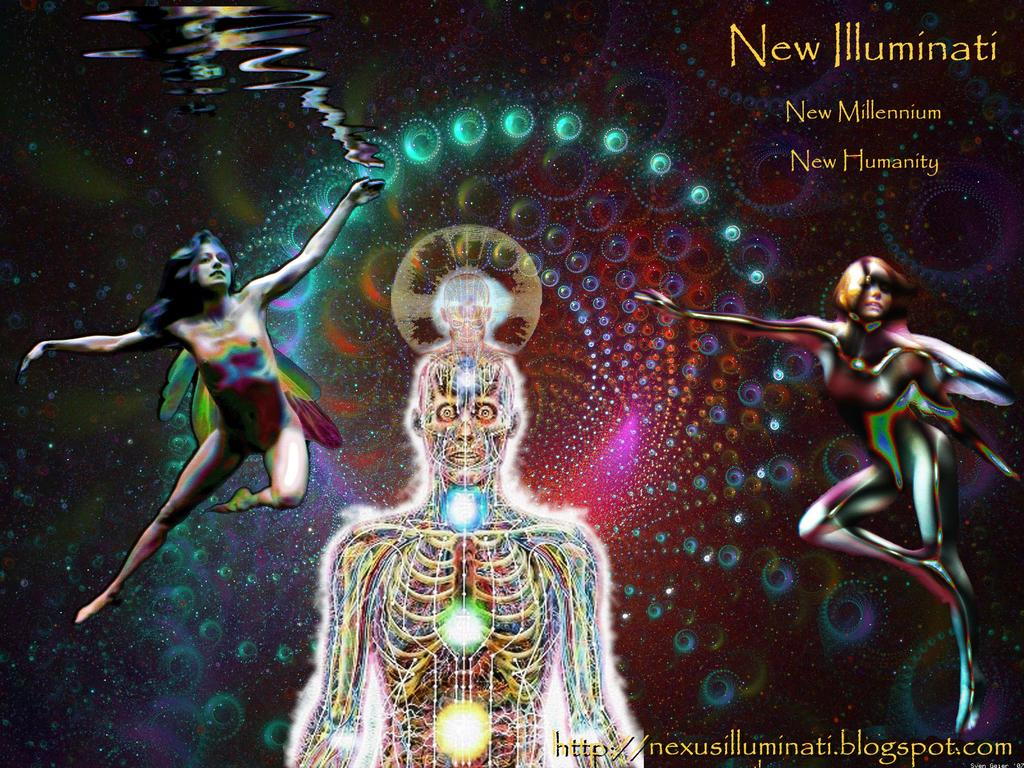Provide a one-sentence caption for the provided image. A colorful skeleton and two other human figures on a poster of New Illuminati. 